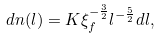Convert formula to latex. <formula><loc_0><loc_0><loc_500><loc_500>d n ( l ) = K \xi _ { f } ^ { - \frac { 3 } { 2 } } l ^ { - \frac { 5 } { 2 } } d l ,</formula> 